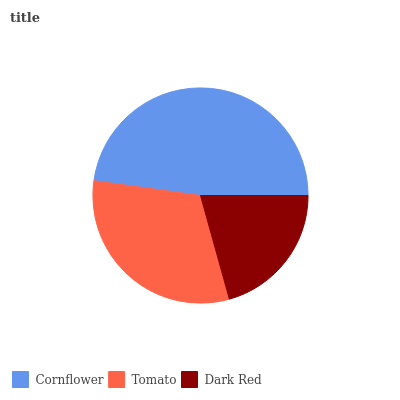Is Dark Red the minimum?
Answer yes or no. Yes. Is Cornflower the maximum?
Answer yes or no. Yes. Is Tomato the minimum?
Answer yes or no. No. Is Tomato the maximum?
Answer yes or no. No. Is Cornflower greater than Tomato?
Answer yes or no. Yes. Is Tomato less than Cornflower?
Answer yes or no. Yes. Is Tomato greater than Cornflower?
Answer yes or no. No. Is Cornflower less than Tomato?
Answer yes or no. No. Is Tomato the high median?
Answer yes or no. Yes. Is Tomato the low median?
Answer yes or no. Yes. Is Dark Red the high median?
Answer yes or no. No. Is Dark Red the low median?
Answer yes or no. No. 